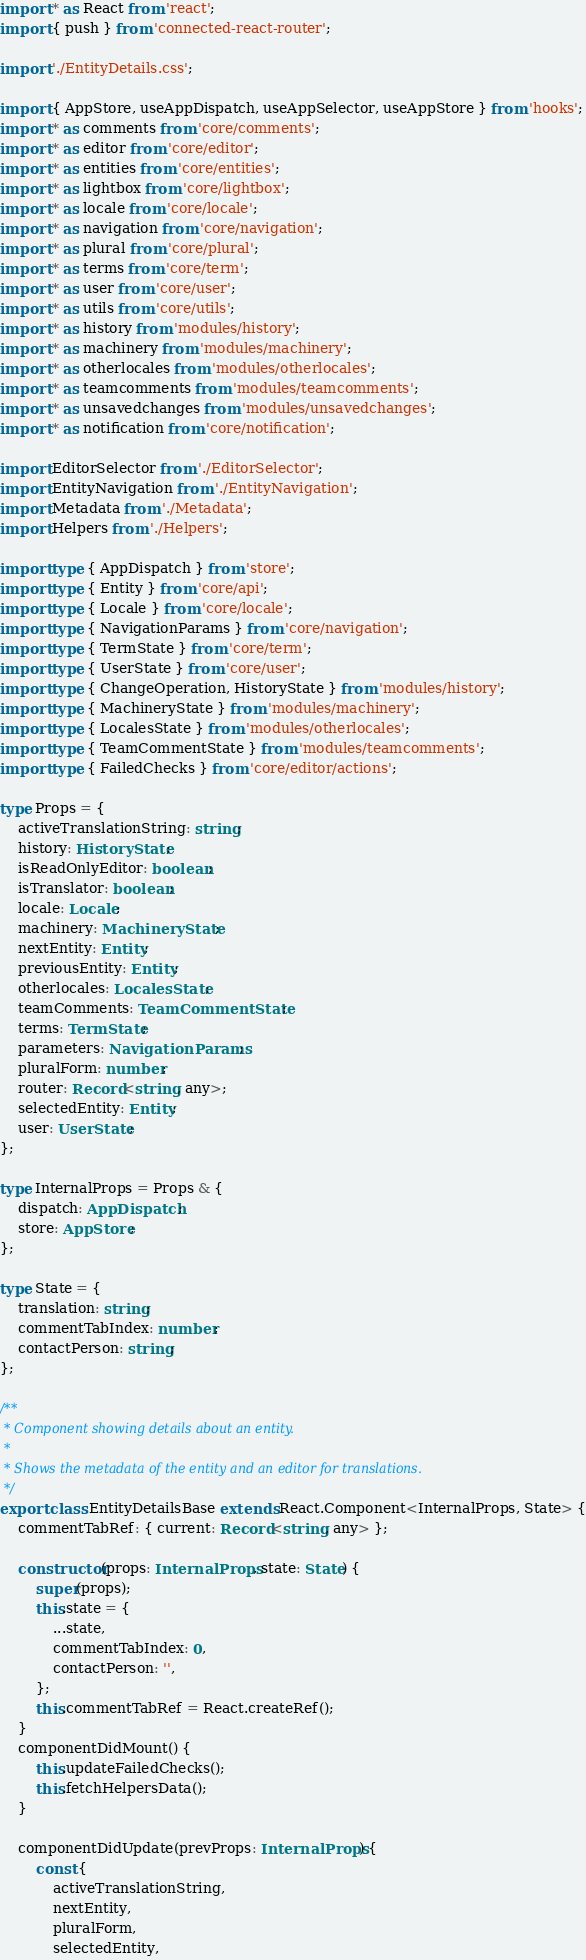<code> <loc_0><loc_0><loc_500><loc_500><_TypeScript_>import * as React from 'react';
import { push } from 'connected-react-router';

import './EntityDetails.css';

import { AppStore, useAppDispatch, useAppSelector, useAppStore } from 'hooks';
import * as comments from 'core/comments';
import * as editor from 'core/editor';
import * as entities from 'core/entities';
import * as lightbox from 'core/lightbox';
import * as locale from 'core/locale';
import * as navigation from 'core/navigation';
import * as plural from 'core/plural';
import * as terms from 'core/term';
import * as user from 'core/user';
import * as utils from 'core/utils';
import * as history from 'modules/history';
import * as machinery from 'modules/machinery';
import * as otherlocales from 'modules/otherlocales';
import * as teamcomments from 'modules/teamcomments';
import * as unsavedchanges from 'modules/unsavedchanges';
import * as notification from 'core/notification';

import EditorSelector from './EditorSelector';
import EntityNavigation from './EntityNavigation';
import Metadata from './Metadata';
import Helpers from './Helpers';

import type { AppDispatch } from 'store';
import type { Entity } from 'core/api';
import type { Locale } from 'core/locale';
import type { NavigationParams } from 'core/navigation';
import type { TermState } from 'core/term';
import type { UserState } from 'core/user';
import type { ChangeOperation, HistoryState } from 'modules/history';
import type { MachineryState } from 'modules/machinery';
import type { LocalesState } from 'modules/otherlocales';
import type { TeamCommentState } from 'modules/teamcomments';
import type { FailedChecks } from 'core/editor/actions';

type Props = {
    activeTranslationString: string;
    history: HistoryState;
    isReadOnlyEditor: boolean;
    isTranslator: boolean;
    locale: Locale;
    machinery: MachineryState;
    nextEntity: Entity;
    previousEntity: Entity;
    otherlocales: LocalesState;
    teamComments: TeamCommentState;
    terms: TermState;
    parameters: NavigationParams;
    pluralForm: number;
    router: Record<string, any>;
    selectedEntity: Entity;
    user: UserState;
};

type InternalProps = Props & {
    dispatch: AppDispatch;
    store: AppStore;
};

type State = {
    translation: string;
    commentTabIndex: number;
    contactPerson: string;
};

/**
 * Component showing details about an entity.
 *
 * Shows the metadata of the entity and an editor for translations.
 */
export class EntityDetailsBase extends React.Component<InternalProps, State> {
    commentTabRef: { current: Record<string, any> };

    constructor(props: InternalProps, state: State) {
        super(props);
        this.state = {
            ...state,
            commentTabIndex: 0,
            contactPerson: '',
        };
        this.commentTabRef = React.createRef();
    }
    componentDidMount() {
        this.updateFailedChecks();
        this.fetchHelpersData();
    }

    componentDidUpdate(prevProps: InternalProps) {
        const {
            activeTranslationString,
            nextEntity,
            pluralForm,
            selectedEntity,</code> 